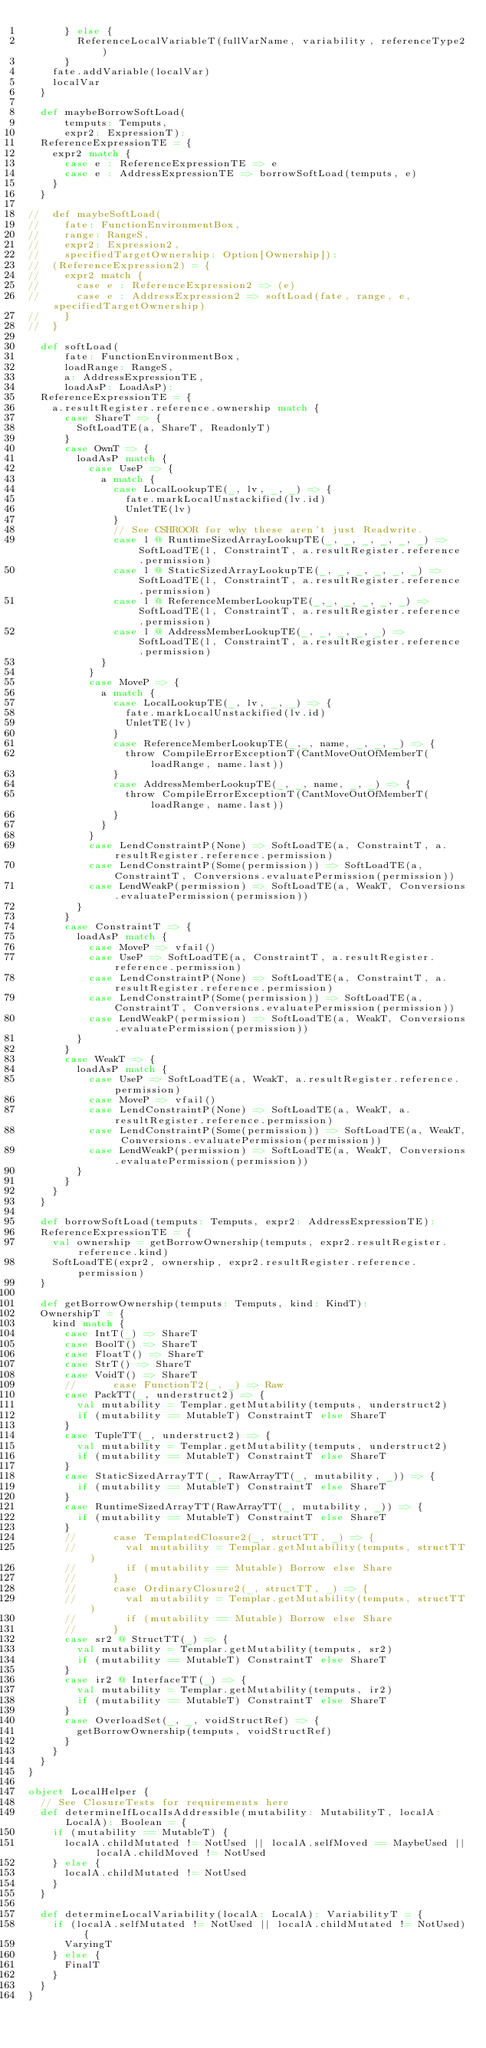Convert code to text. <code><loc_0><loc_0><loc_500><loc_500><_Scala_>      } else {
        ReferenceLocalVariableT(fullVarName, variability, referenceType2)
      }
    fate.addVariable(localVar)
    localVar
  }

  def maybeBorrowSoftLoad(
      temputs: Temputs,
      expr2: ExpressionT):
  ReferenceExpressionTE = {
    expr2 match {
      case e : ReferenceExpressionTE => e
      case e : AddressExpressionTE => borrowSoftLoad(temputs, e)
    }
  }

//  def maybeSoftLoad(
//    fate: FunctionEnvironmentBox,
//    range: RangeS,
//    expr2: Expression2,
//    specifiedTargetOwnership: Option[Ownership]):
//  (ReferenceExpression2) = {
//    expr2 match {
//      case e : ReferenceExpression2 => (e)
//      case e : AddressExpression2 => softLoad(fate, range, e, specifiedTargetOwnership)
//    }
//  }

  def softLoad(
      fate: FunctionEnvironmentBox,
      loadRange: RangeS,
      a: AddressExpressionTE,
      loadAsP: LoadAsP):
  ReferenceExpressionTE = {
    a.resultRegister.reference.ownership match {
      case ShareT => {
        SoftLoadTE(a, ShareT, ReadonlyT)
      }
      case OwnT => {
        loadAsP match {
          case UseP => {
            a match {
              case LocalLookupTE(_, lv, _, _) => {
                fate.markLocalUnstackified(lv.id)
                UnletTE(lv)
              }
              // See CSHROOR for why these aren't just Readwrite.
              case l @ RuntimeSizedArrayLookupTE(_, _, _, _, _, _) => SoftLoadTE(l, ConstraintT, a.resultRegister.reference.permission)
              case l @ StaticSizedArrayLookupTE(_, _, _, _, _, _) => SoftLoadTE(l, ConstraintT, a.resultRegister.reference.permission)
              case l @ ReferenceMemberLookupTE(_,_, _, _, _, _) => SoftLoadTE(l, ConstraintT, a.resultRegister.reference.permission)
              case l @ AddressMemberLookupTE(_, _, _, _, _) => SoftLoadTE(l, ConstraintT, a.resultRegister.reference.permission)
            }
          }
          case MoveP => {
            a match {
              case LocalLookupTE(_, lv, _, _) => {
                fate.markLocalUnstackified(lv.id)
                UnletTE(lv)
              }
              case ReferenceMemberLookupTE(_,_, name, _, _, _) => {
                throw CompileErrorExceptionT(CantMoveOutOfMemberT(loadRange, name.last))
              }
              case AddressMemberLookupTE(_, _, name, _, _) => {
                throw CompileErrorExceptionT(CantMoveOutOfMemberT(loadRange, name.last))
              }
            }
          }
          case LendConstraintP(None) => SoftLoadTE(a, ConstraintT, a.resultRegister.reference.permission)
          case LendConstraintP(Some(permission)) => SoftLoadTE(a, ConstraintT, Conversions.evaluatePermission(permission))
          case LendWeakP(permission) => SoftLoadTE(a, WeakT, Conversions.evaluatePermission(permission))
        }
      }
      case ConstraintT => {
        loadAsP match {
          case MoveP => vfail()
          case UseP => SoftLoadTE(a, ConstraintT, a.resultRegister.reference.permission)
          case LendConstraintP(None) => SoftLoadTE(a, ConstraintT, a.resultRegister.reference.permission)
          case LendConstraintP(Some(permission)) => SoftLoadTE(a, ConstraintT, Conversions.evaluatePermission(permission))
          case LendWeakP(permission) => SoftLoadTE(a, WeakT, Conversions.evaluatePermission(permission))
        }
      }
      case WeakT => {
        loadAsP match {
          case UseP => SoftLoadTE(a, WeakT, a.resultRegister.reference.permission)
          case MoveP => vfail()
          case LendConstraintP(None) => SoftLoadTE(a, WeakT, a.resultRegister.reference.permission)
          case LendConstraintP(Some(permission)) => SoftLoadTE(a, WeakT, Conversions.evaluatePermission(permission))
          case LendWeakP(permission) => SoftLoadTE(a, WeakT, Conversions.evaluatePermission(permission))
        }
      }
    }
  }

  def borrowSoftLoad(temputs: Temputs, expr2: AddressExpressionTE):
  ReferenceExpressionTE = {
    val ownership = getBorrowOwnership(temputs, expr2.resultRegister.reference.kind)
    SoftLoadTE(expr2, ownership, expr2.resultRegister.reference.permission)
  }

  def getBorrowOwnership(temputs: Temputs, kind: KindT):
  OwnershipT = {
    kind match {
      case IntT(_) => ShareT
      case BoolT() => ShareT
      case FloatT() => ShareT
      case StrT() => ShareT
      case VoidT() => ShareT
      //      case FunctionT2(_, _) => Raw
      case PackTT(_, understruct2) => {
        val mutability = Templar.getMutability(temputs, understruct2)
        if (mutability == MutableT) ConstraintT else ShareT
      }
      case TupleTT(_, understruct2) => {
        val mutability = Templar.getMutability(temputs, understruct2)
        if (mutability == MutableT) ConstraintT else ShareT
      }
      case StaticSizedArrayTT(_, RawArrayTT(_, mutability, _)) => {
        if (mutability == MutableT) ConstraintT else ShareT
      }
      case RuntimeSizedArrayTT(RawArrayTT(_, mutability, _)) => {
        if (mutability == MutableT) ConstraintT else ShareT
      }
      //      case TemplatedClosure2(_, structTT, _) => {
      //        val mutability = Templar.getMutability(temputs, structTT)
      //        if (mutability == Mutable) Borrow else Share
      //      }
      //      case OrdinaryClosure2(_, structTT, _) => {
      //        val mutability = Templar.getMutability(temputs, structTT)
      //        if (mutability == Mutable) Borrow else Share
      //      }
      case sr2 @ StructTT(_) => {
        val mutability = Templar.getMutability(temputs, sr2)
        if (mutability == MutableT) ConstraintT else ShareT
      }
      case ir2 @ InterfaceTT(_) => {
        val mutability = Templar.getMutability(temputs, ir2)
        if (mutability == MutableT) ConstraintT else ShareT
      }
      case OverloadSet(_, _, voidStructRef) => {
        getBorrowOwnership(temputs, voidStructRef)
      }
    }
  }
}

object LocalHelper {
  // See ClosureTests for requirements here
  def determineIfLocalIsAddressible(mutability: MutabilityT, localA: LocalA): Boolean = {
    if (mutability == MutableT) {
      localA.childMutated != NotUsed || localA.selfMoved == MaybeUsed || localA.childMoved != NotUsed
    } else {
      localA.childMutated != NotUsed
    }
  }

  def determineLocalVariability(localA: LocalA): VariabilityT = {
    if (localA.selfMutated != NotUsed || localA.childMutated != NotUsed) {
      VaryingT
    } else {
      FinalT
    }
  }
}</code> 